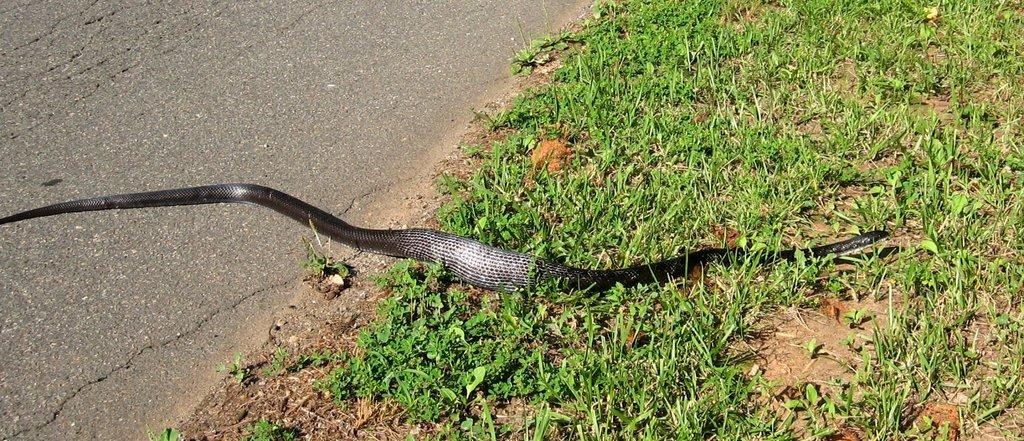What animal is present in the image? There is a snake in the image. Where is the snake located? The snake is on the grass. What type of surface is the image taken on? The image was taken on a road. At what time of day was the image taken? The image was taken during the day. What type of star can be seen in the oven in the image? There is no oven or star present in the image; it features a snake on the grass. 